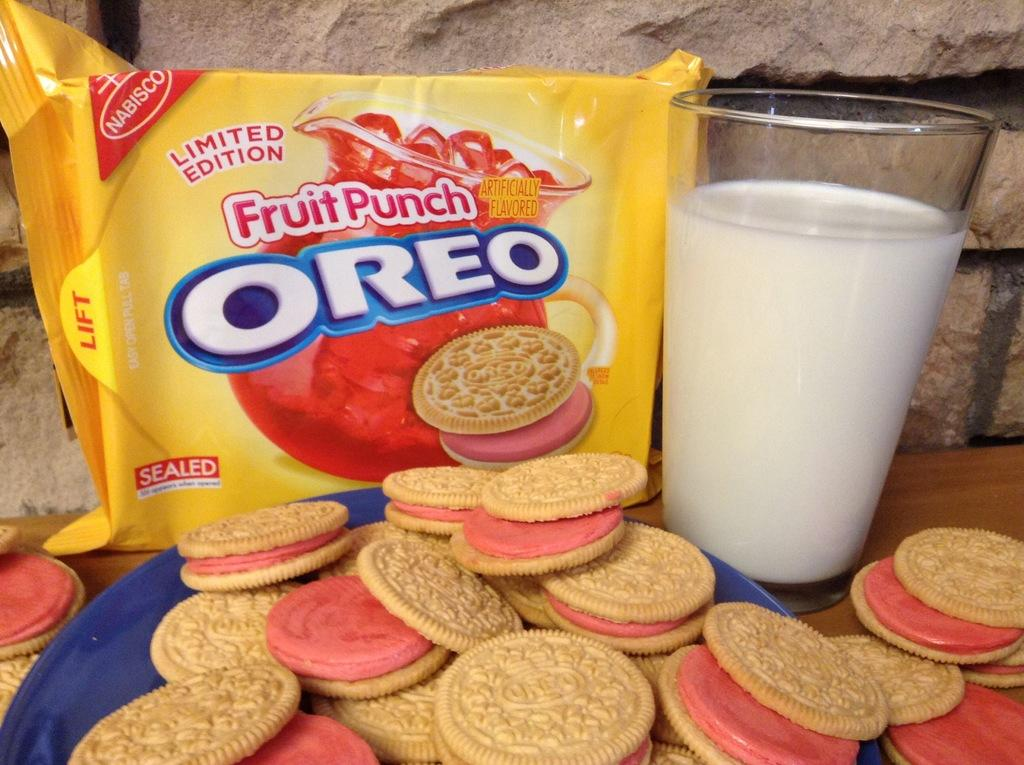What type of biscuits are in the closed packet in the image? There is a closed packet of Oreo biscuits in the image. What is placed next to the biscuits in the image? There is a glass of milk in the image. How are the biscuits arranged in the image? Biscuits are placed on a blue color plate in the image. What is the surface made of that the items are placed on? The items are placed on a wooden surface. Can you see a monkey holding a gun in the image? No, there is no monkey or gun present in the image. 